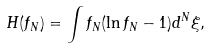<formula> <loc_0><loc_0><loc_500><loc_500>H ( f _ { N } ) = \int f _ { N } ( \ln f _ { N } - 1 ) d ^ { N } \xi ,</formula> 